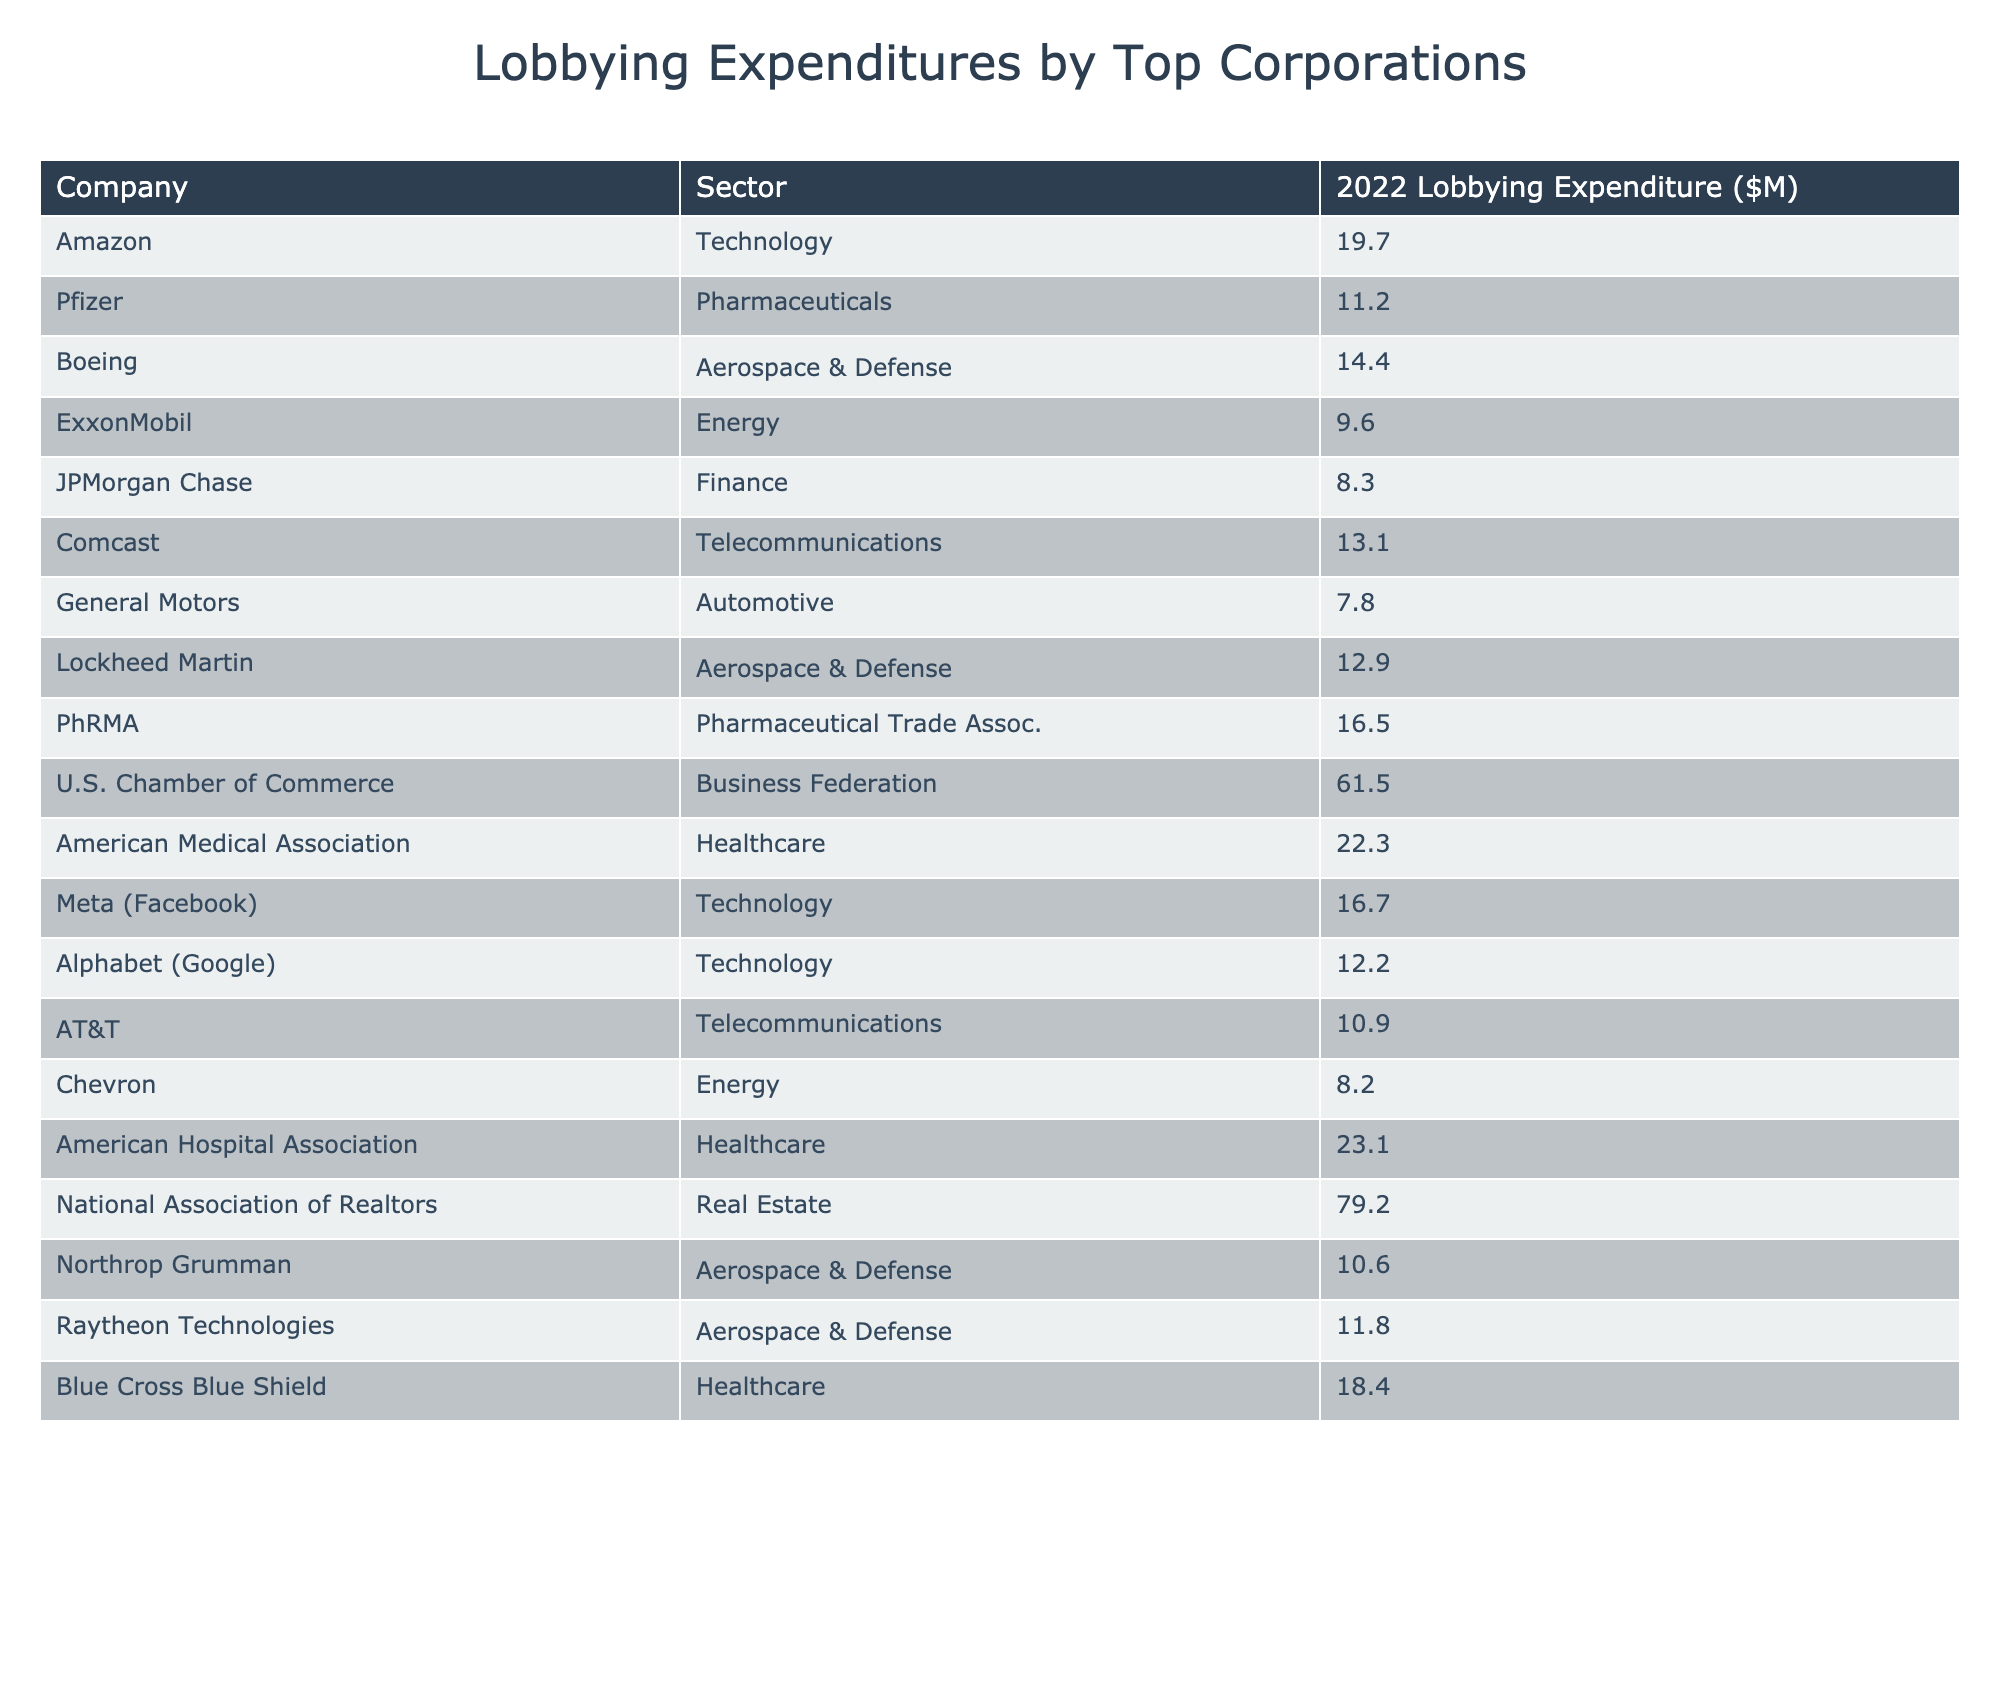What is the lobbying expenditure of Amazon? Amazon's lobbying expenditure is listed directly in the table under its respective row, which states that it spent $19.7 million in 2022.
Answer: 19.7 million Which sector had the highest lobbying expenditure? By examining the industries listed in the table, the "Business Federation" sector for the U.S. Chamber of Commerce shows the highest expenditure at $61.5 million.
Answer: Business Federation How much did the Aerospace & Defense sector spend in total on lobbying? To find the total for the Aerospace & Defense sector, sum the individual expenditures from Boeing ($14.4M), Lockheed Martin ($12.9M), Northrop Grumman ($10.6M), and Raytheon Technologies ($11.8M). This totals to $14.4M + $12.9M + $10.6M + $11.8M = $49.7 million.
Answer: 49.7 million Is it true that Chevron's lobbying expenditure is greater than that of JPMorgan Chase? By checking the expenditures, Chevron is listed at $8.2 million and JPMorgan Chase at $8.3 million; since $8.2 million is less than $8.3 million, this statement is false.
Answer: False What is the average lobbying expenditure of the Technology sector? The Technology sector expenditures amount to Amazon ($19.7M), Meta ($16.7M), and Alphabet ($12.2M), leading to a calculation of the average: (19.7 + 16.7 + 12.2) / 3 = 16.23 million.
Answer: 16.23 million Which company spent less than $10 million on lobbying? Reviewing the expenditures shows that both ExxonMobil ($9.6M) and Chevron ($8.2M) are under $10 million, while other companies listed have higher amounts.
Answer: ExxonMobil and Chevron If we exclude the highest and lowest expenditure from the total, what is the sum of the remaining lobbying expenditures? The highest expenditure is from the U.S. Chamber of Commerce at $61.5 million, and the lowest is Chevron at $8.2 million. Total expenditures are $19.7 + $11.2 + $14.4 + $9.6 + $8.3 + $13.1 + $7.8 + $12.9 + $16.5 + $61.5 + $22.3 + $16.7 + $12.2 + $10.9 + $8.2 + $23.1 + $79.2 + $10.6 + $11.8 + $18.4 = $396.3 million. Excluding the highest and lowest gives us $396.3 - 61.5 - 8.2 = $326.6 million.
Answer: 326.6 million Which company from the Healthcare sector has the highest expenditure? Among the companies listed in the Healthcare sector, the American Hospital Association shows the highest expenditure at $23.1 million.
Answer: American Hospital Association Are there more companies in the Pharmaceuticals sector or the Telecommunications sector? The Pharmaceuticals sector has two companies (Pfizer, PhRMA), while the Telecommunications sector also has two companies (Comcast, AT&T), making their counts equal.
Answer: Equal quantity 